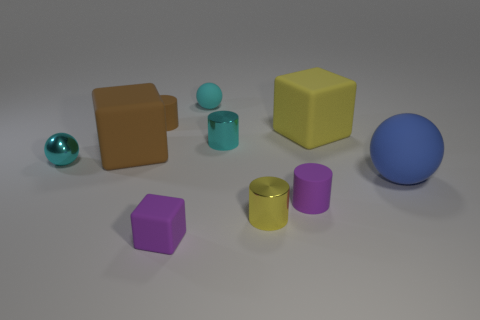There is a cylinder that is the same color as the small rubber cube; what is its material?
Offer a very short reply. Rubber. Do the metallic ball and the tiny rubber sphere have the same color?
Ensure brevity in your answer.  Yes. There is a cyan thing that is behind the big yellow object; what is its material?
Your answer should be very brief. Rubber. There is a tiny block; does it have the same color as the tiny rubber cylinder that is in front of the large yellow matte thing?
Provide a succinct answer. Yes. How many objects are either small things on the left side of the tiny cyan rubber thing or rubber balls that are in front of the small brown rubber cylinder?
Provide a short and direct response. 4. What color is the rubber thing that is in front of the large blue rubber ball and behind the tiny yellow metallic cylinder?
Offer a terse response. Purple. Is the number of small blue metallic cylinders greater than the number of brown matte cylinders?
Offer a very short reply. No. There is a yellow thing that is in front of the blue rubber object; is its shape the same as the blue matte thing?
Offer a terse response. No. How many matte objects are cyan objects or blue objects?
Provide a succinct answer. 2. Is there a brown cylinder made of the same material as the brown block?
Keep it short and to the point. Yes. 